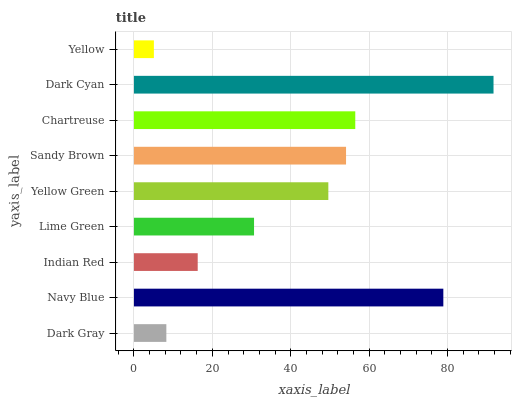Is Yellow the minimum?
Answer yes or no. Yes. Is Dark Cyan the maximum?
Answer yes or no. Yes. Is Navy Blue the minimum?
Answer yes or no. No. Is Navy Blue the maximum?
Answer yes or no. No. Is Navy Blue greater than Dark Gray?
Answer yes or no. Yes. Is Dark Gray less than Navy Blue?
Answer yes or no. Yes. Is Dark Gray greater than Navy Blue?
Answer yes or no. No. Is Navy Blue less than Dark Gray?
Answer yes or no. No. Is Yellow Green the high median?
Answer yes or no. Yes. Is Yellow Green the low median?
Answer yes or no. Yes. Is Chartreuse the high median?
Answer yes or no. No. Is Navy Blue the low median?
Answer yes or no. No. 